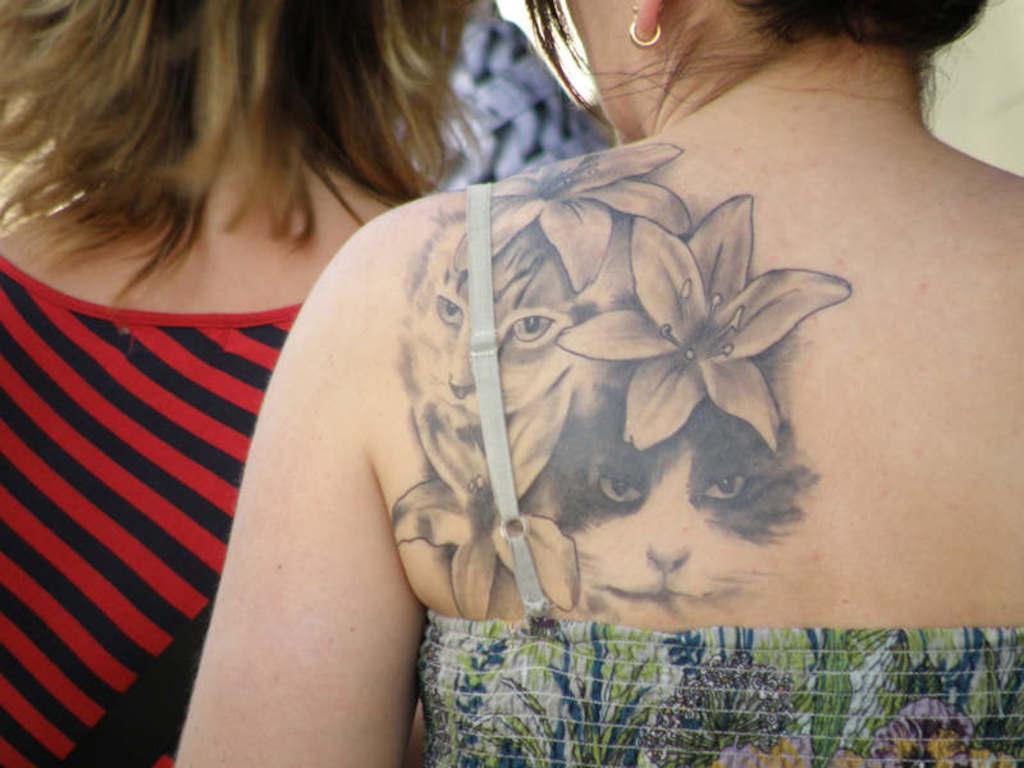Describe this image in one or two sentences. In this image there are two persons, a person with a tattoo on her skin. 